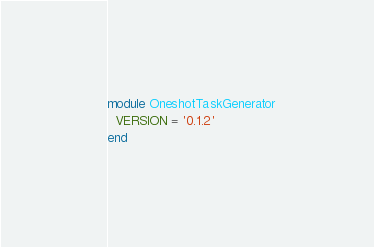<code> <loc_0><loc_0><loc_500><loc_500><_Ruby_>module OneshotTaskGenerator
  VERSION = '0.1.2'
end
</code> 